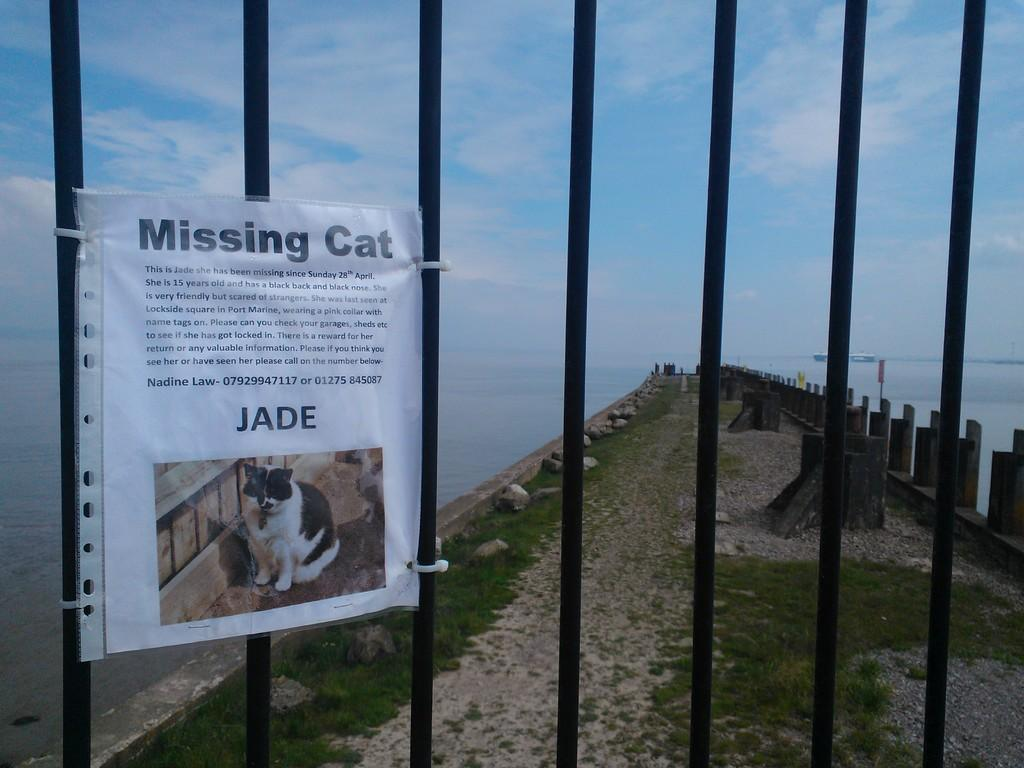What type of object is featured in the image? There is an advertising poster in the image. Where is the poster located? The poster is on a grill. What can be seen in the background of the image? There is a bridge visible in the image. What is the bridge situated over? The bridge is over water. What type of soup is being served on the bridge in the image? There is no soup or any indication of food being served in the image; it features an advertising poster on a grill and a bridge over water. 